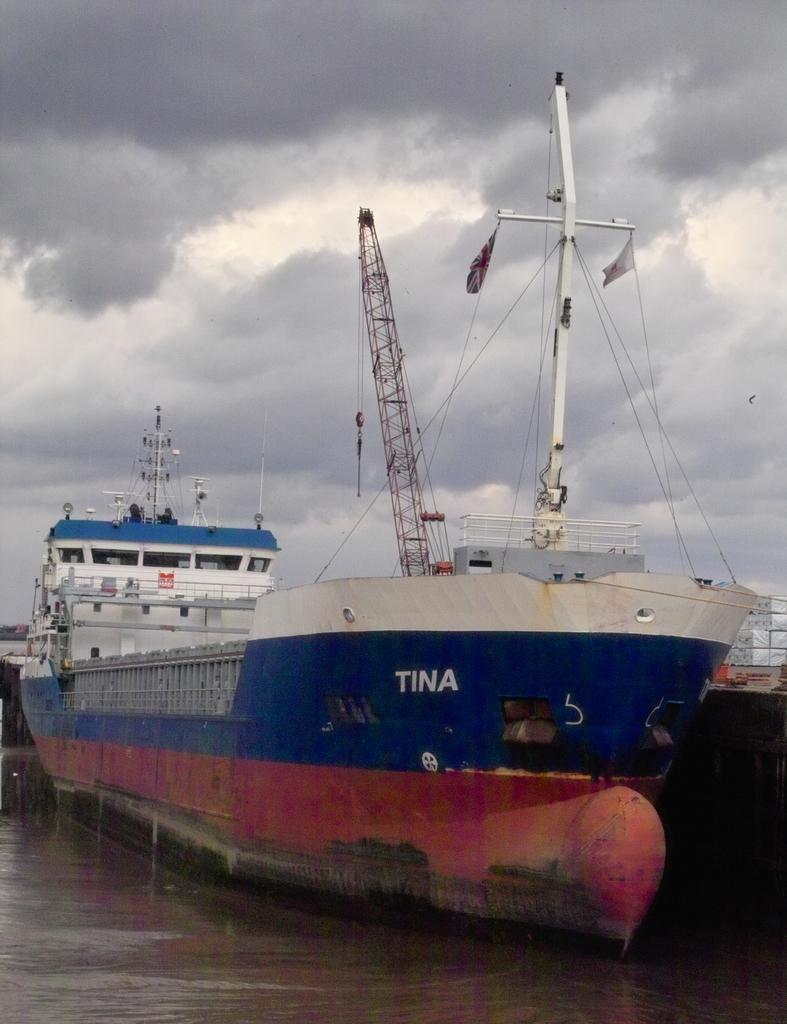Could you give a brief overview of what you see in this image? In this image we can see ship which is in blue, red and white which is in water and top of the image there is cloudy sky. 